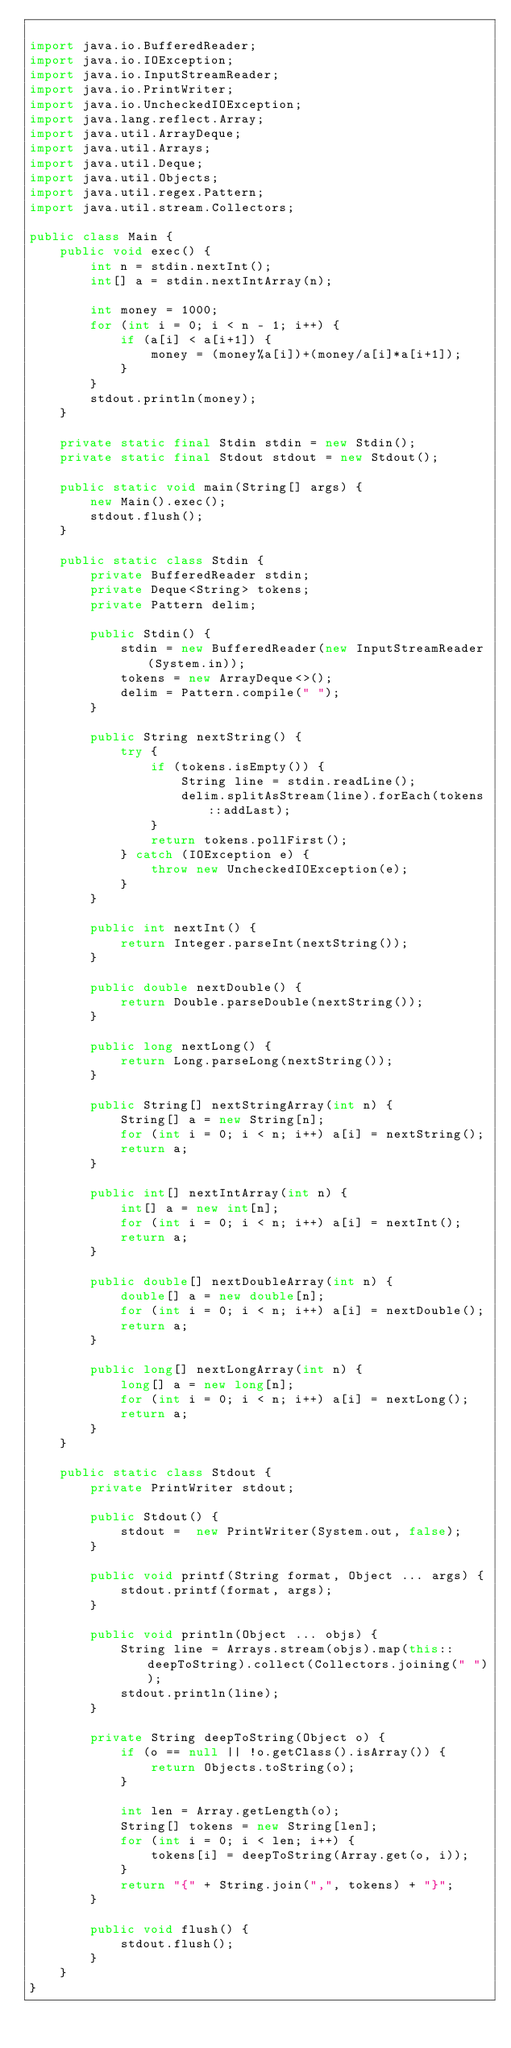<code> <loc_0><loc_0><loc_500><loc_500><_Java_>
import java.io.BufferedReader;
import java.io.IOException;
import java.io.InputStreamReader;
import java.io.PrintWriter;
import java.io.UncheckedIOException;
import java.lang.reflect.Array;
import java.util.ArrayDeque;
import java.util.Arrays;
import java.util.Deque;
import java.util.Objects;
import java.util.regex.Pattern;
import java.util.stream.Collectors;

public class Main {
    public void exec() {
        int n = stdin.nextInt();
        int[] a = stdin.nextIntArray(n);

        int money = 1000;
        for (int i = 0; i < n - 1; i++) {
            if (a[i] < a[i+1]) {
                money = (money%a[i])+(money/a[i]*a[i+1]);
            }
        }
        stdout.println(money);
    }

    private static final Stdin stdin = new Stdin();
    private static final Stdout stdout = new Stdout();

    public static void main(String[] args) {
        new Main().exec();
        stdout.flush();
    }

    public static class Stdin {
        private BufferedReader stdin;
        private Deque<String> tokens;
        private Pattern delim;

        public Stdin() {
            stdin = new BufferedReader(new InputStreamReader(System.in));
            tokens = new ArrayDeque<>();
            delim = Pattern.compile(" ");
        }

        public String nextString() {
            try {
                if (tokens.isEmpty()) {
                    String line = stdin.readLine();
                    delim.splitAsStream(line).forEach(tokens::addLast);
                }
                return tokens.pollFirst();
            } catch (IOException e) {
                throw new UncheckedIOException(e);
            }
        }

        public int nextInt() {
            return Integer.parseInt(nextString());
        }

        public double nextDouble() {
            return Double.parseDouble(nextString());
        }

        public long nextLong() {
            return Long.parseLong(nextString());
        }

        public String[] nextStringArray(int n) {
            String[] a = new String[n];
            for (int i = 0; i < n; i++) a[i] = nextString();
            return a;
        }

        public int[] nextIntArray(int n) {
            int[] a = new int[n];
            for (int i = 0; i < n; i++) a[i] = nextInt();
            return a;
        }

        public double[] nextDoubleArray(int n) {
            double[] a = new double[n];
            for (int i = 0; i < n; i++) a[i] = nextDouble();
            return a;
        }

        public long[] nextLongArray(int n) {
            long[] a = new long[n];
            for (int i = 0; i < n; i++) a[i] = nextLong();
            return a;
        }
    }

    public static class Stdout {
        private PrintWriter stdout;

        public Stdout() {
            stdout =  new PrintWriter(System.out, false);
        }

        public void printf(String format, Object ... args) {
            stdout.printf(format, args);
        }

        public void println(Object ... objs) {
            String line = Arrays.stream(objs).map(this::deepToString).collect(Collectors.joining(" "));
            stdout.println(line);
        }

        private String deepToString(Object o) {
            if (o == null || !o.getClass().isArray()) {
                return Objects.toString(o);
            }

            int len = Array.getLength(o);
            String[] tokens = new String[len];
            for (int i = 0; i < len; i++) {
                tokens[i] = deepToString(Array.get(o, i));
            }
            return "{" + String.join(",", tokens) + "}";
        }

        public void flush() {
            stdout.flush();
        }
    }
}
</code> 